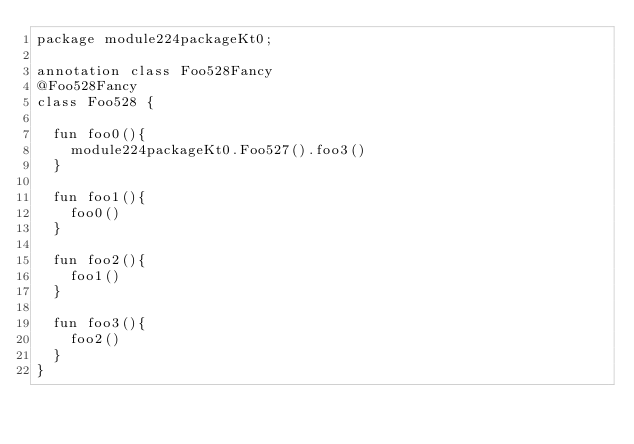<code> <loc_0><loc_0><loc_500><loc_500><_Kotlin_>package module224packageKt0;

annotation class Foo528Fancy
@Foo528Fancy
class Foo528 {

  fun foo0(){
    module224packageKt0.Foo527().foo3()
  }

  fun foo1(){
    foo0()
  }

  fun foo2(){
    foo1()
  }

  fun foo3(){
    foo2()
  }
}</code> 